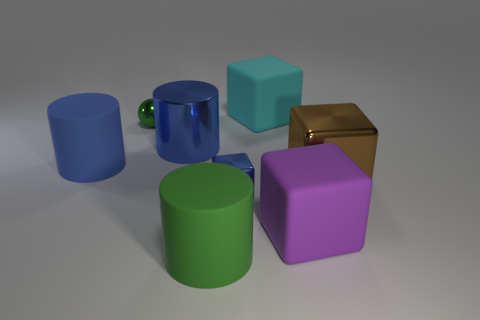Subtract 1 cubes. How many cubes are left? 3 Add 1 large green metallic cylinders. How many objects exist? 9 Subtract all cylinders. How many objects are left? 5 Subtract all large metal blocks. Subtract all tiny green things. How many objects are left? 6 Add 1 green shiny things. How many green shiny things are left? 2 Add 2 big red rubber spheres. How many big red rubber spheres exist? 2 Subtract 1 blue cubes. How many objects are left? 7 